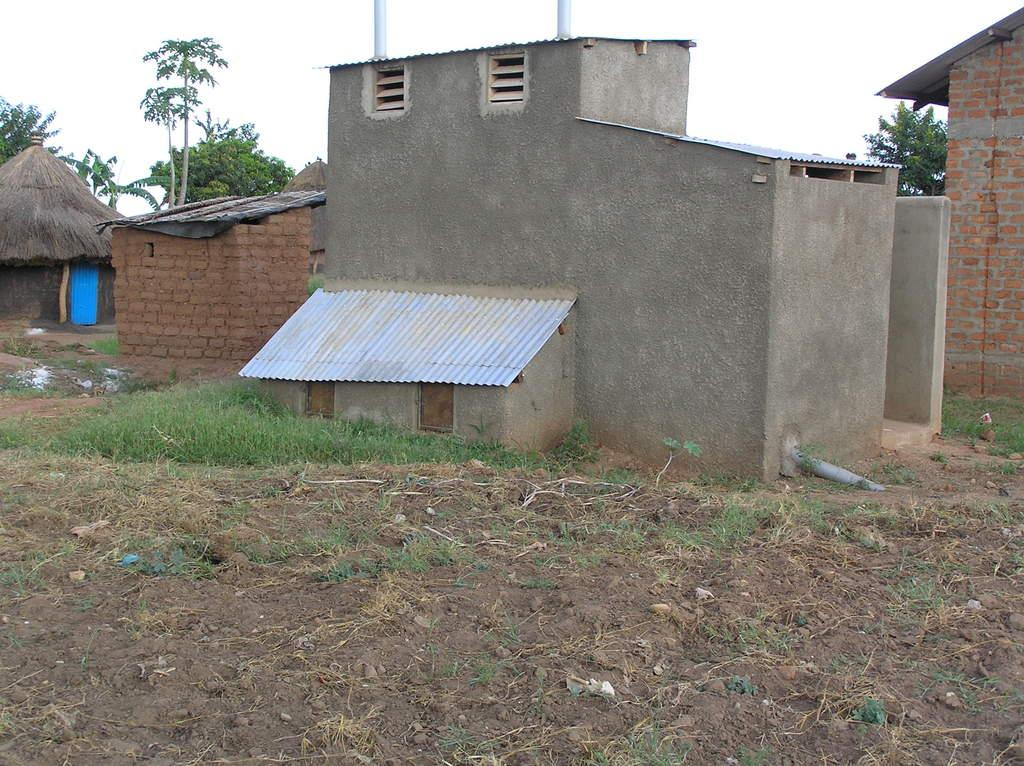Where was the picture taken? The picture was clicked outside. What can be seen in the center of the image? There are buildings and a hut in the center of the image, along with green grass. What is visible in the background of the image? There is a sky and trees visible in the background of the image. How does the plant wave its head in the image? There is no plant or head visible in the image. 